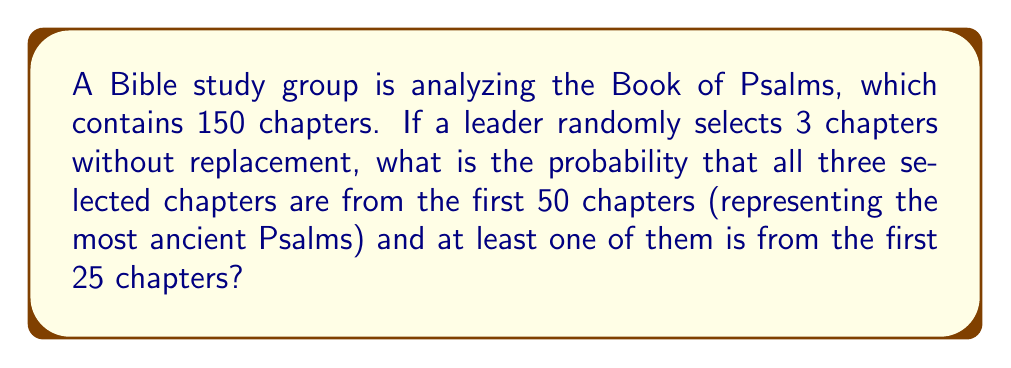Teach me how to tackle this problem. Let's approach this step-by-step:

1) First, we need to calculate the total number of ways to select 3 chapters out of 150:
   $${150 \choose 3} = \frac{150!}{3!(150-3)!} = 551,300$$

2) Now, we need to calculate the number of favorable outcomes. We can do this by subtracting the number of ways to select 3 chapters from chapters 26-50 from the total number of ways to select 3 chapters from the first 50:

   $${50 \choose 3} - {25 \choose 3} = \frac{50!}{3!(50-3)!} - \frac{25!}{3!(25-3)!} = 19,600 - 2,300 = 17,300$$

3) The probability is then:

   $$P(\text{all from first 50, at least one from first 25}) = \frac{17,300}{551,300}$$

4) Simplifying this fraction:

   $$\frac{17,300}{551,300} = \frac{173}{5,513} \approx 0.0314$$

Therefore, the probability is $\frac{173}{5,513}$ or approximately 3.14%.
Answer: $\frac{173}{5,513}$ 